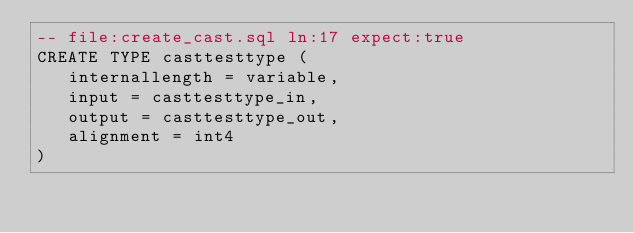<code> <loc_0><loc_0><loc_500><loc_500><_SQL_>-- file:create_cast.sql ln:17 expect:true
CREATE TYPE casttesttype (
   internallength = variable,
   input = casttesttype_in,
   output = casttesttype_out,
   alignment = int4
)
</code> 